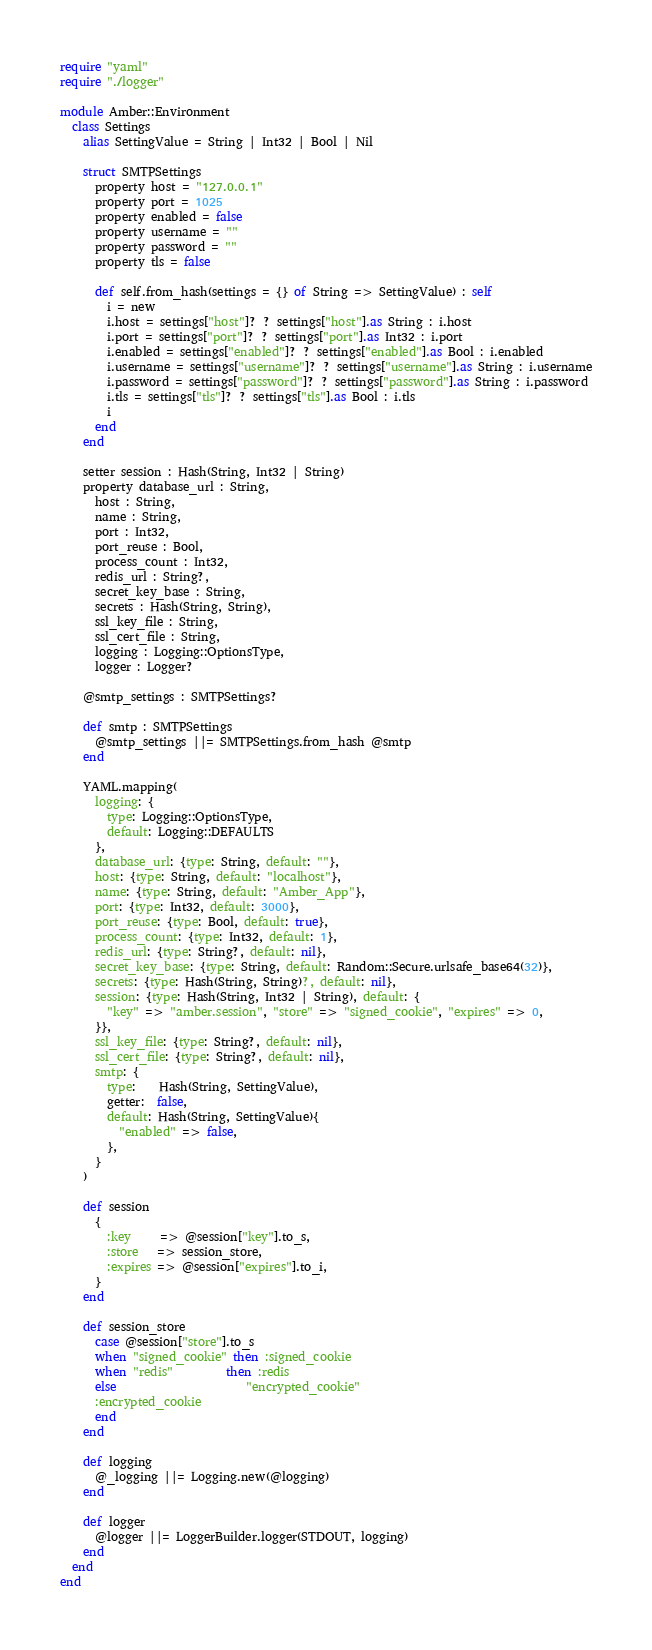<code> <loc_0><loc_0><loc_500><loc_500><_Crystal_>require "yaml"
require "./logger"

module Amber::Environment
  class Settings
    alias SettingValue = String | Int32 | Bool | Nil

    struct SMTPSettings
      property host = "127.0.0.1"
      property port = 1025
      property enabled = false
      property username = ""
      property password = ""
      property tls = false

      def self.from_hash(settings = {} of String => SettingValue) : self
        i = new
        i.host = settings["host"]? ? settings["host"].as String : i.host
        i.port = settings["port"]? ? settings["port"].as Int32 : i.port
        i.enabled = settings["enabled"]? ? settings["enabled"].as Bool : i.enabled
        i.username = settings["username"]? ? settings["username"].as String : i.username
        i.password = settings["password"]? ? settings["password"].as String : i.password
        i.tls = settings["tls"]? ? settings["tls"].as Bool : i.tls
        i
      end
    end

    setter session : Hash(String, Int32 | String)
    property database_url : String,
      host : String,
      name : String,
      port : Int32,
      port_reuse : Bool,
      process_count : Int32,
      redis_url : String?,
      secret_key_base : String,
      secrets : Hash(String, String),
      ssl_key_file : String,
      ssl_cert_file : String,
      logging : Logging::OptionsType,
      logger : Logger?

    @smtp_settings : SMTPSettings?

    def smtp : SMTPSettings
      @smtp_settings ||= SMTPSettings.from_hash @smtp
    end

    YAML.mapping(
      logging: {
        type: Logging::OptionsType,
        default: Logging::DEFAULTS
      },
      database_url: {type: String, default: ""},
      host: {type: String, default: "localhost"},
      name: {type: String, default: "Amber_App"},
      port: {type: Int32, default: 3000},
      port_reuse: {type: Bool, default: true},
      process_count: {type: Int32, default: 1},
      redis_url: {type: String?, default: nil},
      secret_key_base: {type: String, default: Random::Secure.urlsafe_base64(32)},
      secrets: {type: Hash(String, String)?, default: nil},
      session: {type: Hash(String, Int32 | String), default: {
        "key" => "amber.session", "store" => "signed_cookie", "expires" => 0,
      }},
      ssl_key_file: {type: String?, default: nil},
      ssl_cert_file: {type: String?, default: nil},
      smtp: {
        type:    Hash(String, SettingValue),
        getter:  false,
        default: Hash(String, SettingValue){
          "enabled" => false,
        },
      }
    )

    def session
      {
        :key     => @session["key"].to_s,
        :store   => session_store,
        :expires => @session["expires"].to_i,
      }
    end

    def session_store
      case @session["store"].to_s
      when "signed_cookie" then :signed_cookie
      when "redis"         then :redis
      else                      "encrypted_cookie"
      :encrypted_cookie
      end
    end

    def logging
      @_logging ||= Logging.new(@logging)
    end

    def logger
      @logger ||= LoggerBuilder.logger(STDOUT, logging)
    end
  end
end
</code> 